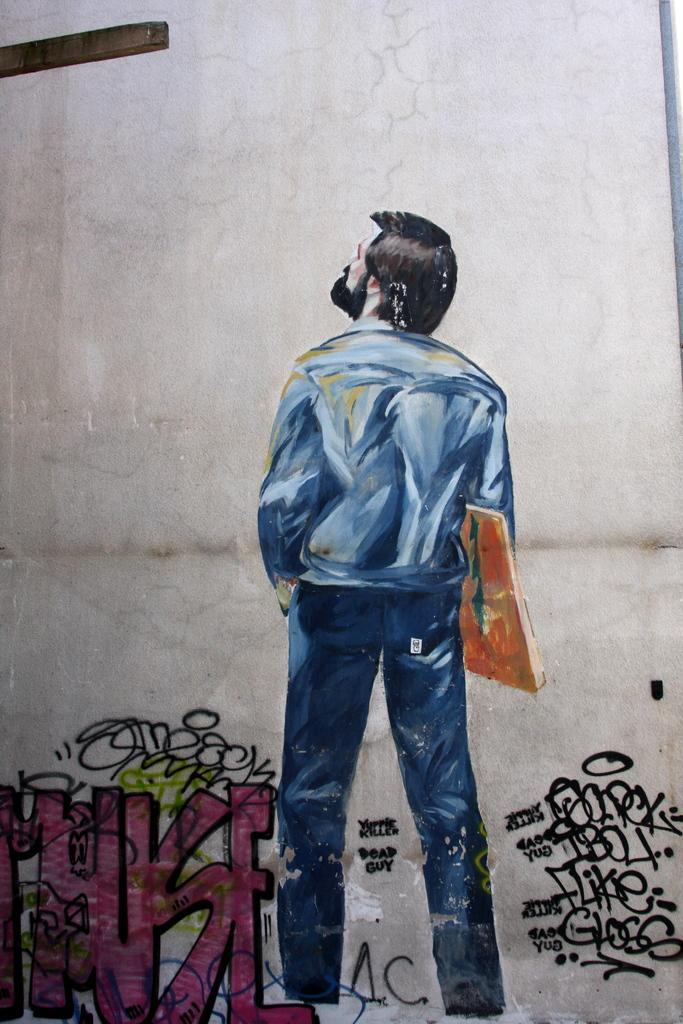What type of artwork is shown in the image? The image is a painting. Who or what is the main subject of the painting? A man is depicted in the painting. What is the man doing in the painting? The man is looking to one side. What is the man wearing in the painting? The man is wearing a shirt and trousers. What object is the man holding in the painting? The man is holding a book in his hand. What can be seen on the left side of the painting? There is text on the left side of the painting. What is the color of the text in the painting? The text is in pink color. Can you see the sun shining on the seashore in the painting? There is no sun or seashore depicted in the painting; it features a man holding a book and text on the left side. Is there a sponge being used by the man in the painting? There is no sponge present in the painting; the man is holding a book. 